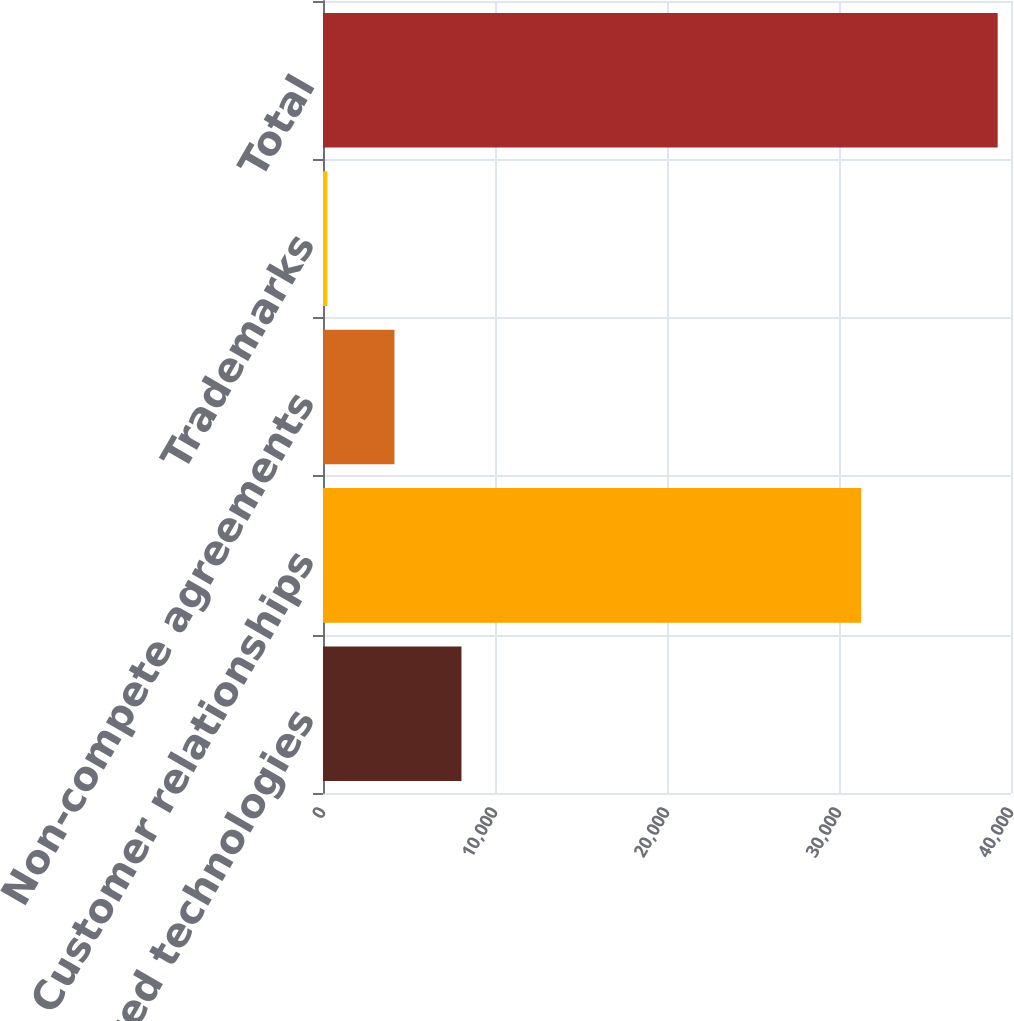Convert chart. <chart><loc_0><loc_0><loc_500><loc_500><bar_chart><fcel>Completed technologies<fcel>Customer relationships<fcel>Non-compete agreements<fcel>Trademarks<fcel>Total<nl><fcel>8050.8<fcel>31291<fcel>4153.9<fcel>257<fcel>39226<nl></chart> 